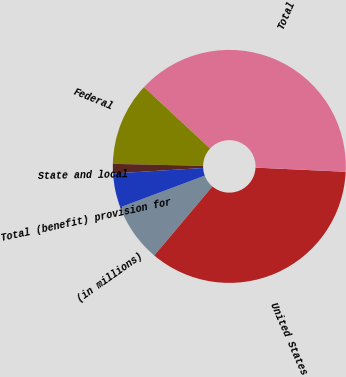Convert chart to OTSL. <chart><loc_0><loc_0><loc_500><loc_500><pie_chart><fcel>(in millions)<fcel>United States<fcel>Total<fcel>Federal<fcel>State and local<fcel>Total (benefit) provision for<nl><fcel>8.15%<fcel>35.4%<fcel>38.82%<fcel>11.57%<fcel>1.32%<fcel>4.74%<nl></chart> 